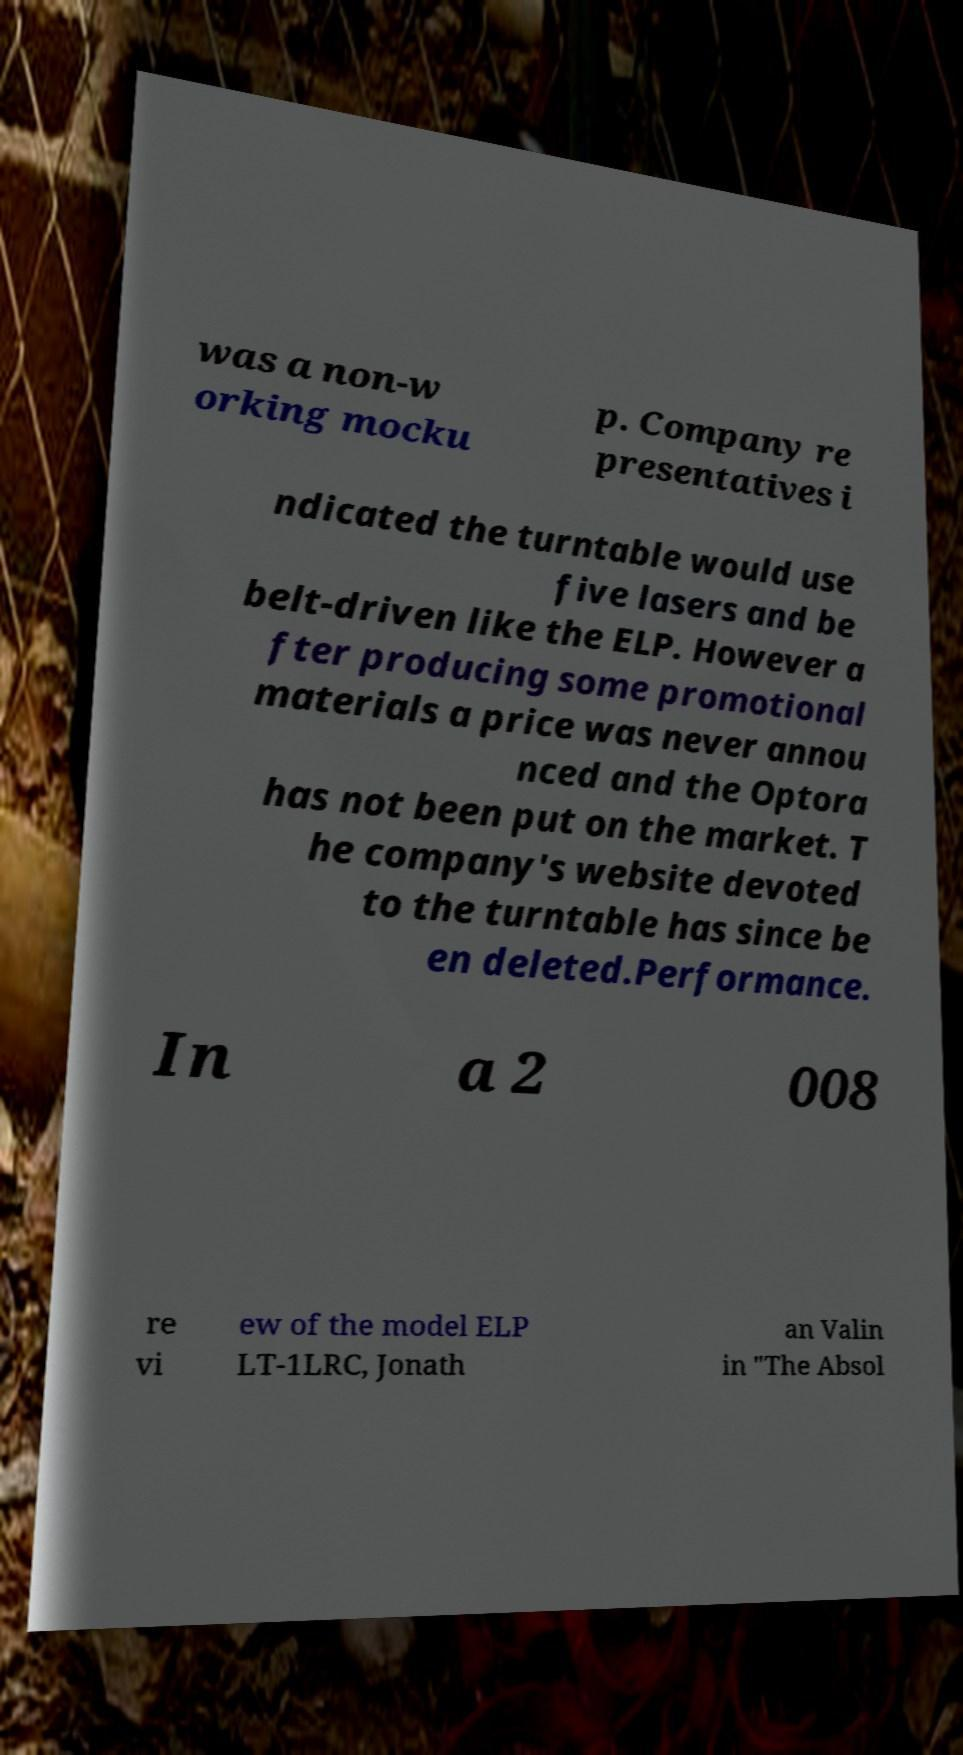Can you accurately transcribe the text from the provided image for me? was a non-w orking mocku p. Company re presentatives i ndicated the turntable would use five lasers and be belt-driven like the ELP. However a fter producing some promotional materials a price was never annou nced and the Optora has not been put on the market. T he company's website devoted to the turntable has since be en deleted.Performance. In a 2 008 re vi ew of the model ELP LT-1LRC, Jonath an Valin in "The Absol 